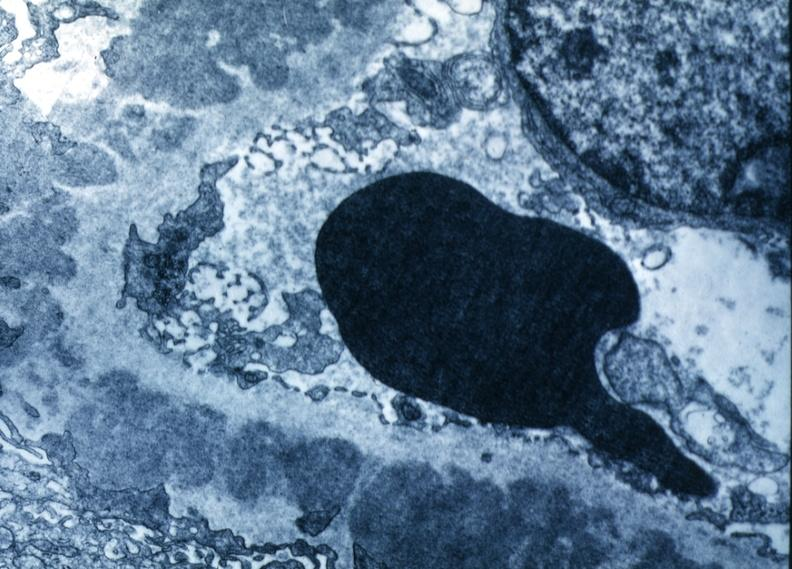where is this?
Answer the question using a single word or phrase. Urinary 